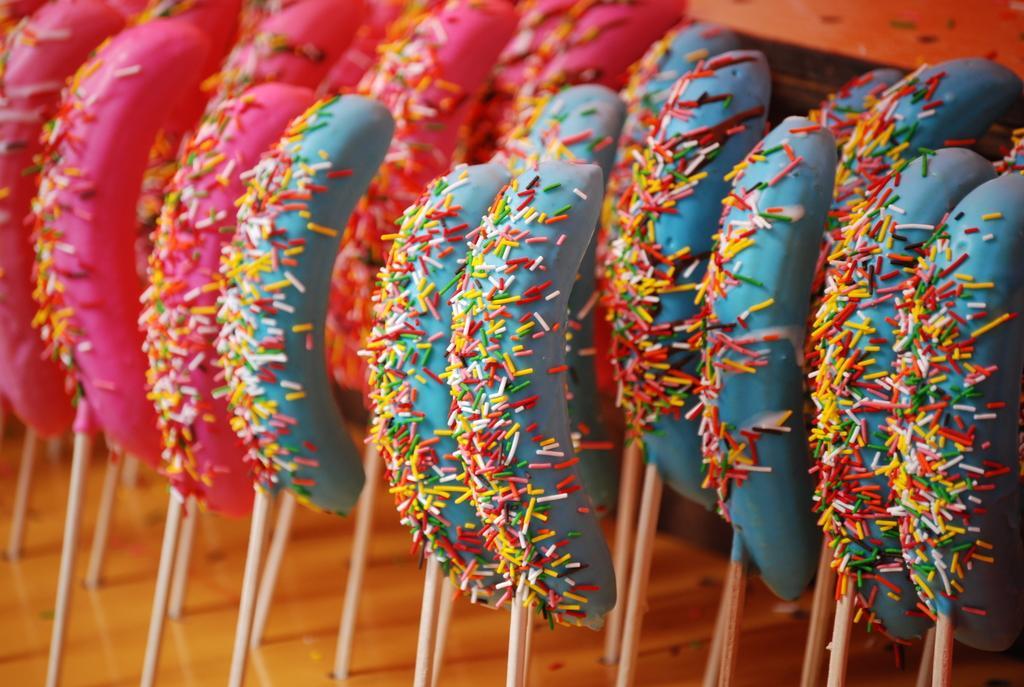How would you summarize this image in a sentence or two? In this image we can see a food with sticks. 